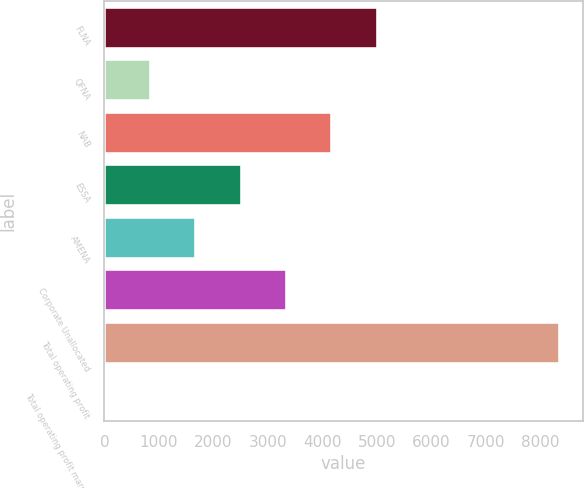Convert chart. <chart><loc_0><loc_0><loc_500><loc_500><bar_chart><fcel>FLNA<fcel>QFNA<fcel>NAB<fcel>ESSA<fcel>AMENA<fcel>Corporate Unallocated<fcel>Total operating profit<fcel>Total operating profit margin<nl><fcel>5017.08<fcel>847.18<fcel>4183.1<fcel>2515.14<fcel>1681.16<fcel>3349.12<fcel>8353<fcel>13.2<nl></chart> 